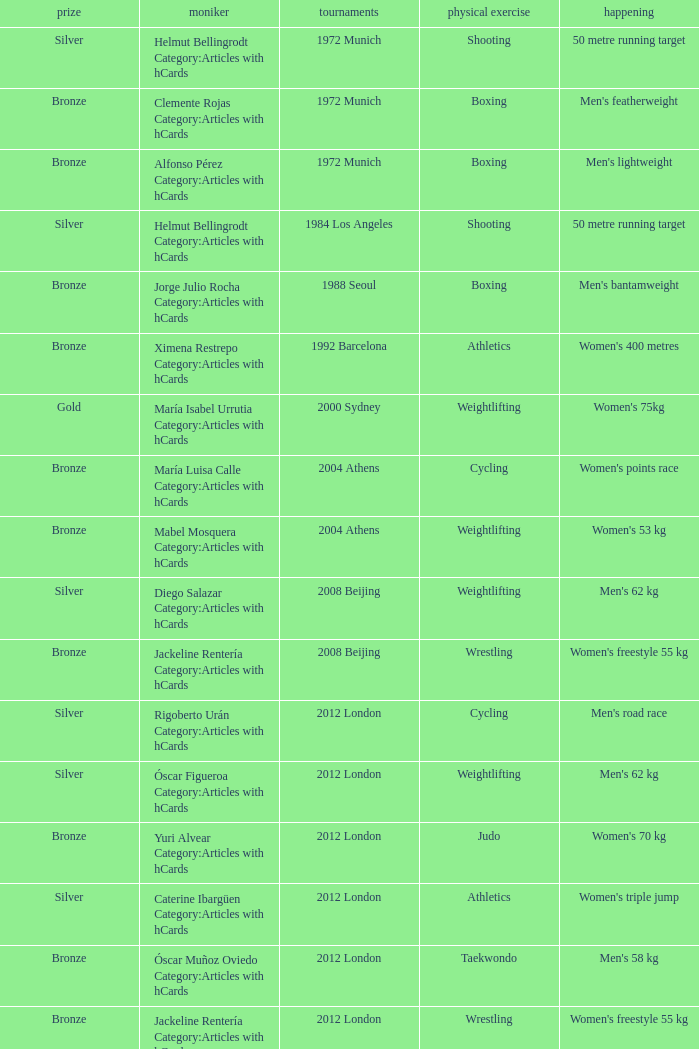What wrestling event was participated in during the 2008 Beijing games? Women's freestyle 55 kg. 